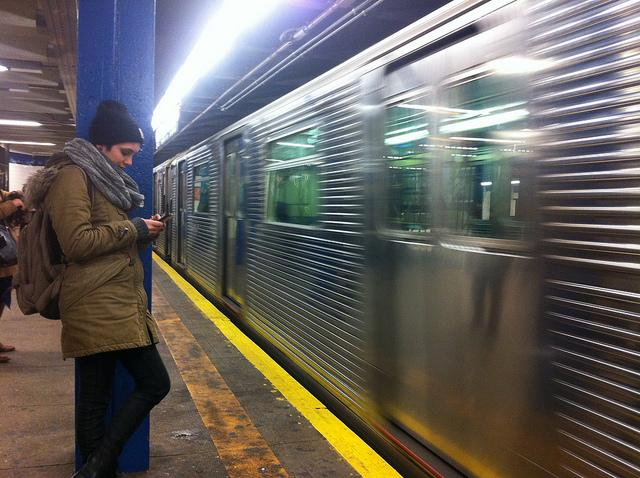What type of communication is she using? Please explain your reasoning. electronic. The person is using electronic communication on their phone. 